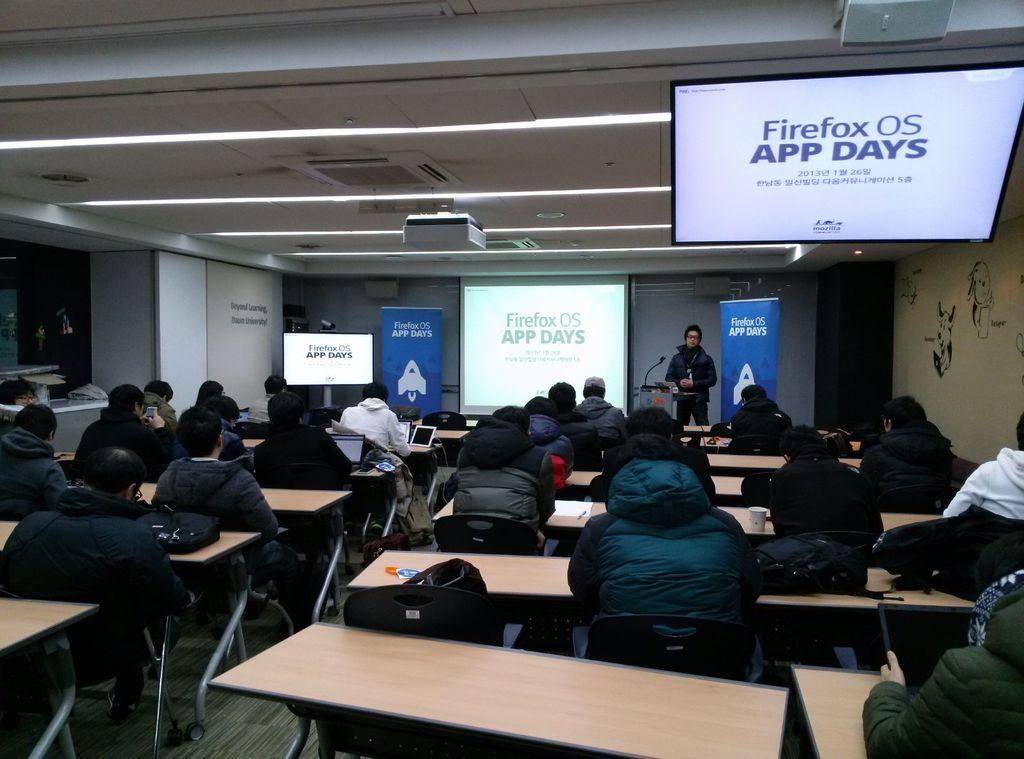Could you give a brief overview of what you see in this image? It is looking like a meeting hall. here I can see few people are sitting on the chairs in front of the tables. In the background there is a man standing. In this room I can see three screens. On the top of the image I can see the lights. On the tables there are some bags and laptops. 